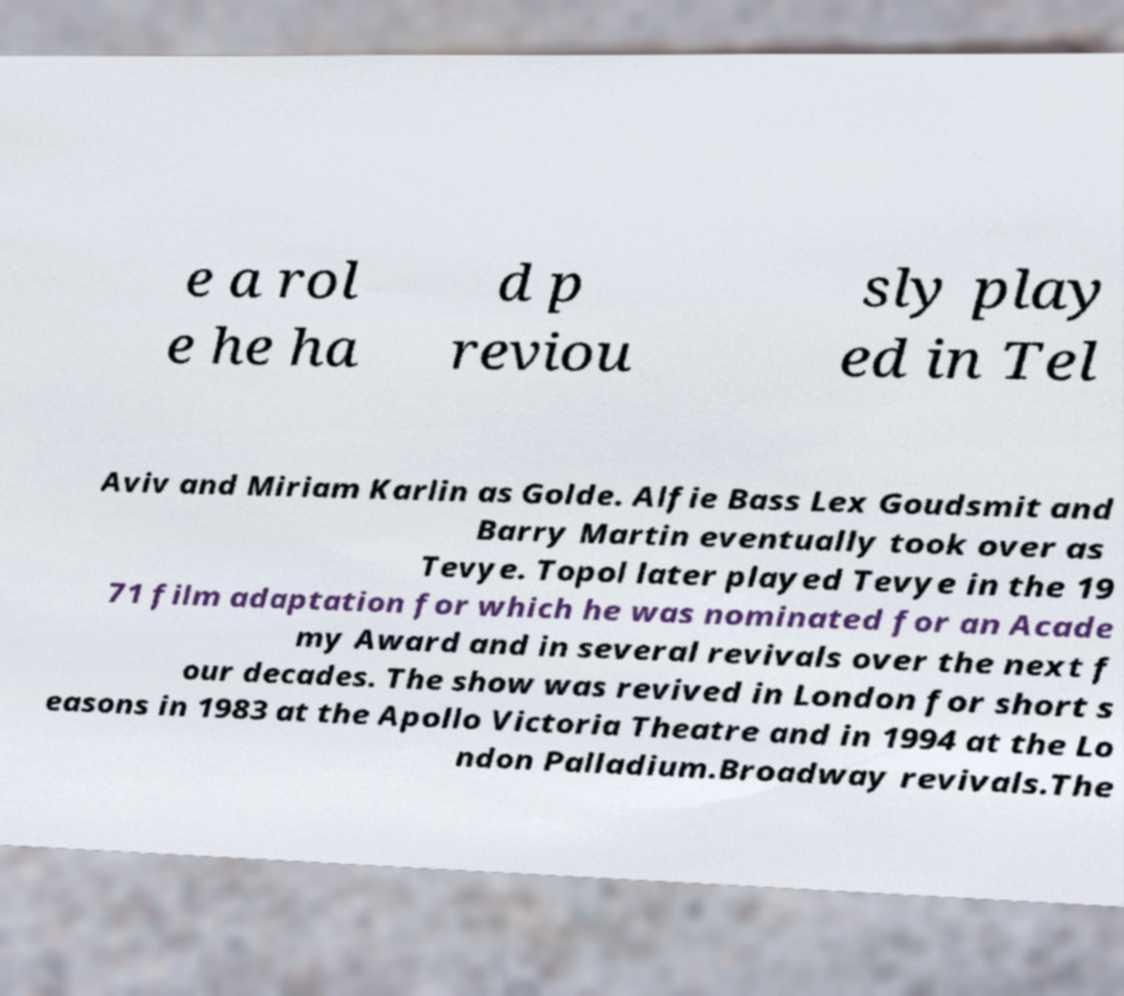Can you accurately transcribe the text from the provided image for me? e a rol e he ha d p reviou sly play ed in Tel Aviv and Miriam Karlin as Golde. Alfie Bass Lex Goudsmit and Barry Martin eventually took over as Tevye. Topol later played Tevye in the 19 71 film adaptation for which he was nominated for an Acade my Award and in several revivals over the next f our decades. The show was revived in London for short s easons in 1983 at the Apollo Victoria Theatre and in 1994 at the Lo ndon Palladium.Broadway revivals.The 